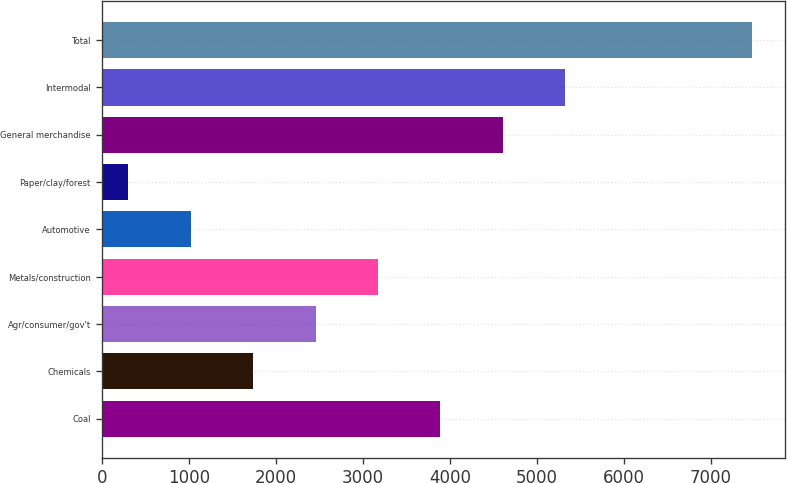<chart> <loc_0><loc_0><loc_500><loc_500><bar_chart><fcel>Coal<fcel>Chemicals<fcel>Agr/consumer/gov't<fcel>Metals/construction<fcel>Automotive<fcel>Paper/clay/forest<fcel>General merchandise<fcel>Intermodal<fcel>Total<nl><fcel>3889.4<fcel>1735.7<fcel>2453.6<fcel>3171.5<fcel>1017.8<fcel>299.9<fcel>4607.3<fcel>5325.2<fcel>7478.9<nl></chart> 